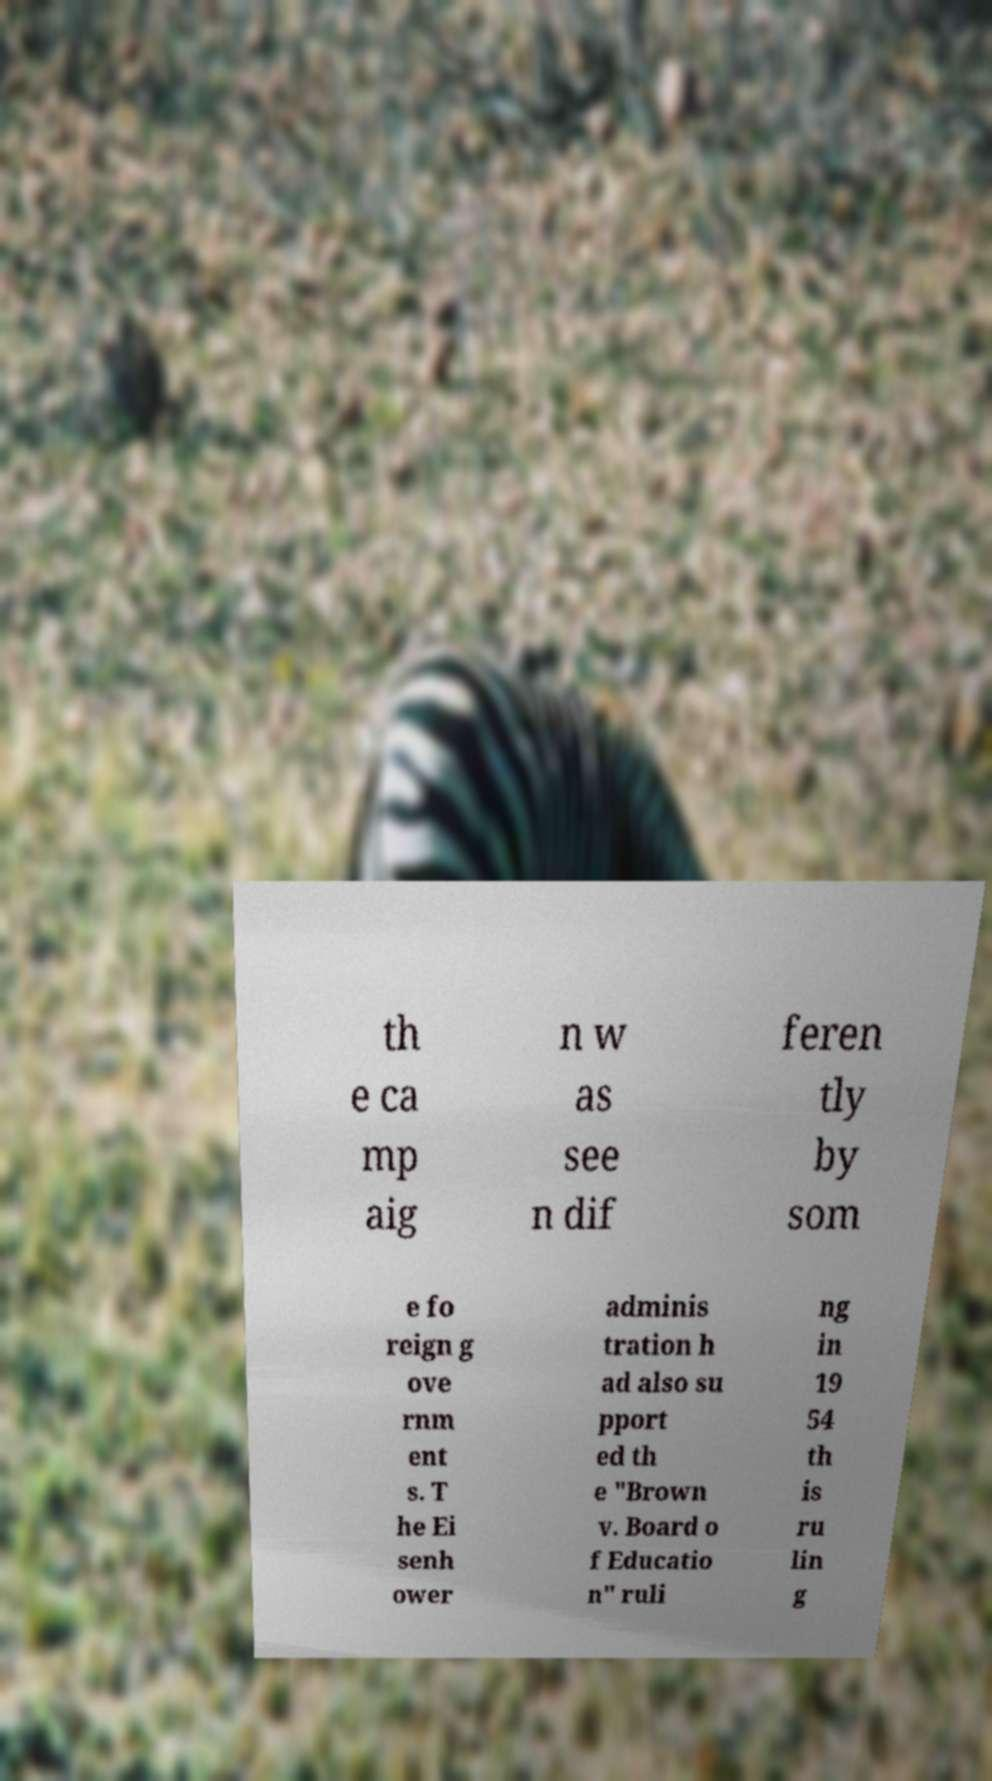What messages or text are displayed in this image? I need them in a readable, typed format. th e ca mp aig n w as see n dif feren tly by som e fo reign g ove rnm ent s. T he Ei senh ower adminis tration h ad also su pport ed th e "Brown v. Board o f Educatio n" ruli ng in 19 54 th is ru lin g 